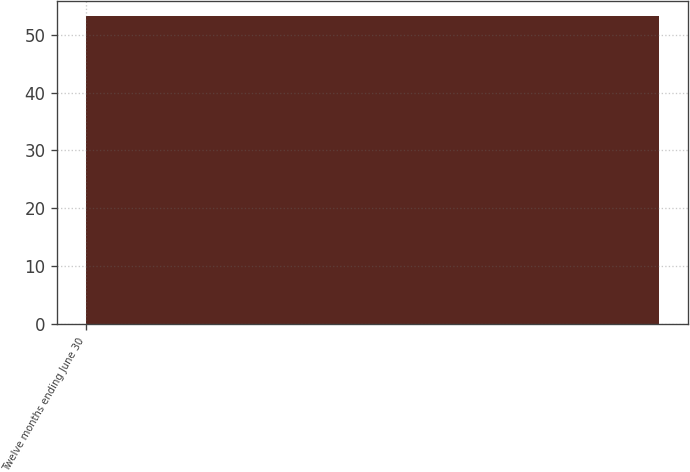<chart> <loc_0><loc_0><loc_500><loc_500><bar_chart><fcel>Twelve months ending June 30<nl><fcel>53.2<nl></chart> 